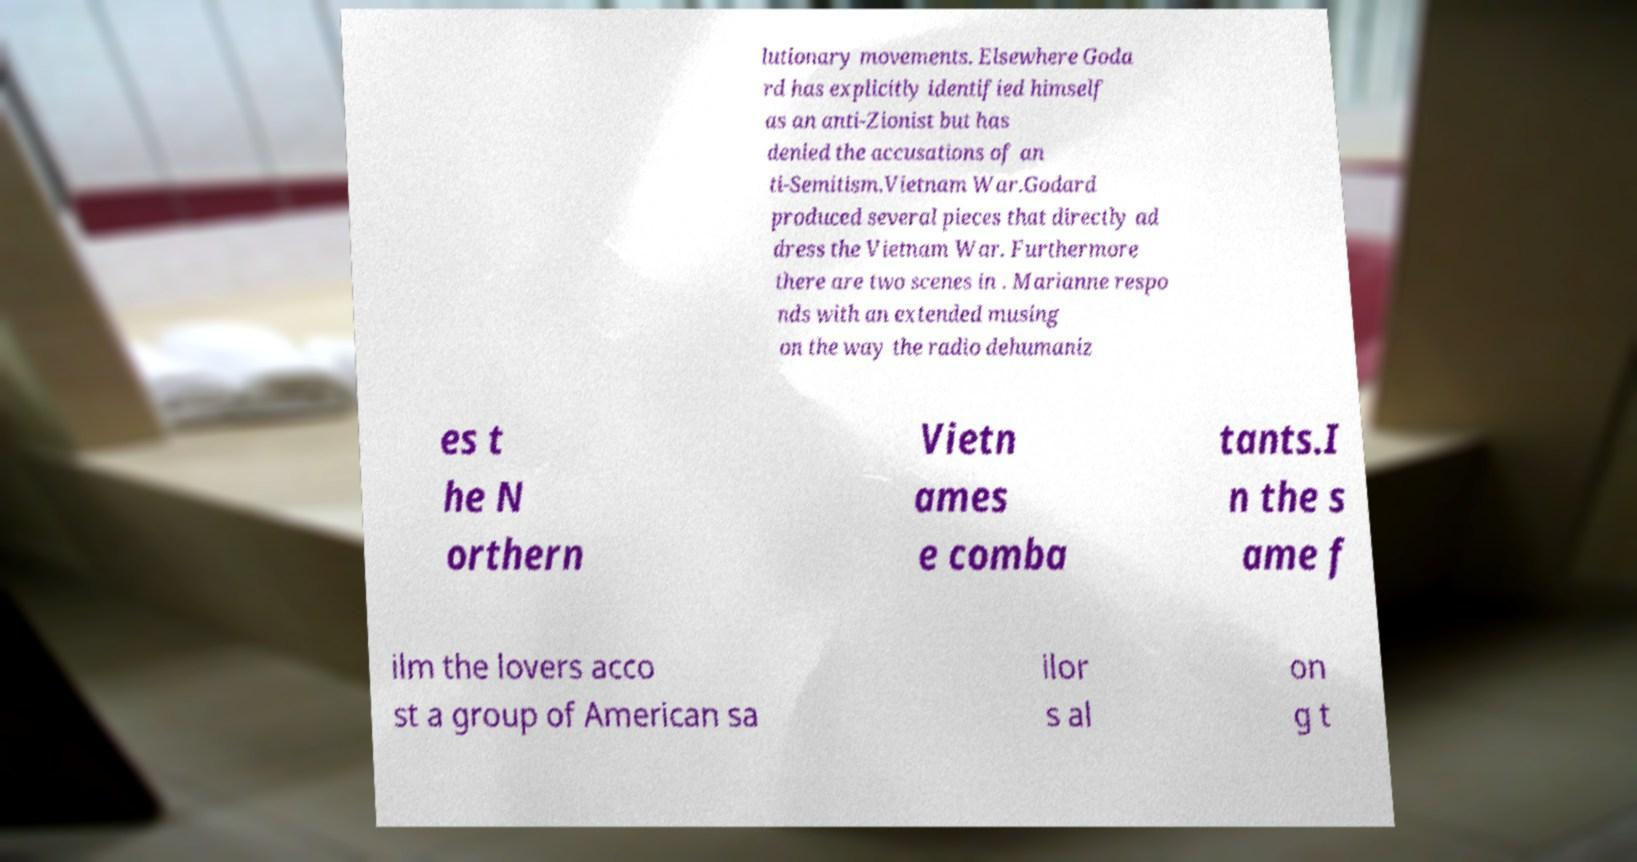There's text embedded in this image that I need extracted. Can you transcribe it verbatim? lutionary movements. Elsewhere Goda rd has explicitly identified himself as an anti-Zionist but has denied the accusations of an ti-Semitism.Vietnam War.Godard produced several pieces that directly ad dress the Vietnam War. Furthermore there are two scenes in . Marianne respo nds with an extended musing on the way the radio dehumaniz es t he N orthern Vietn ames e comba tants.I n the s ame f ilm the lovers acco st a group of American sa ilor s al on g t 